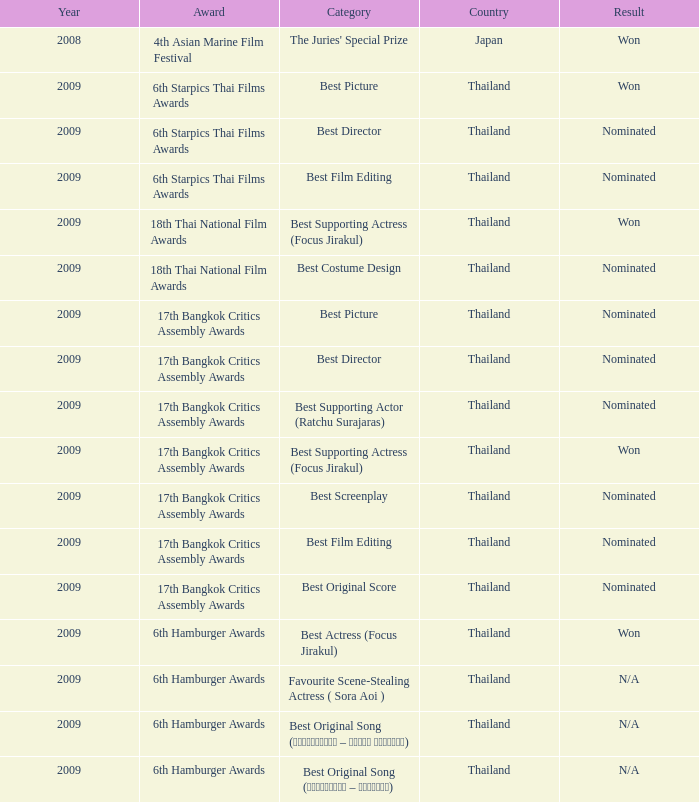Which Year has an Award of 17th bangkok critics assembly awards, and a Category of best original score? 2009.0. 